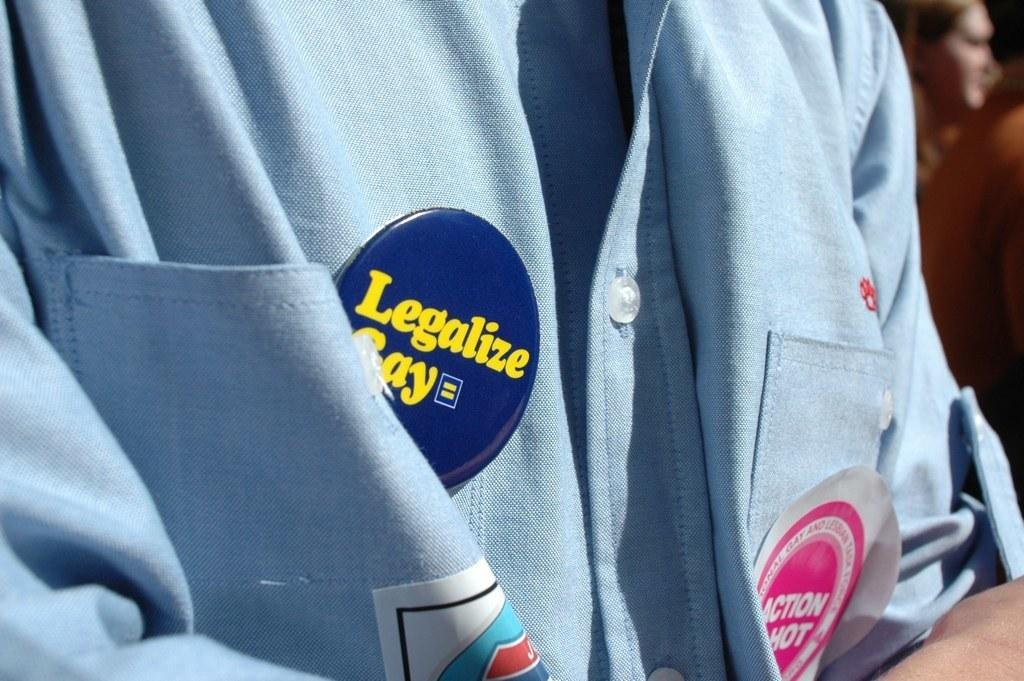<image>
Share a concise interpretation of the image provided. A person in a blue shirt with a badge reading Legalize Gay. 